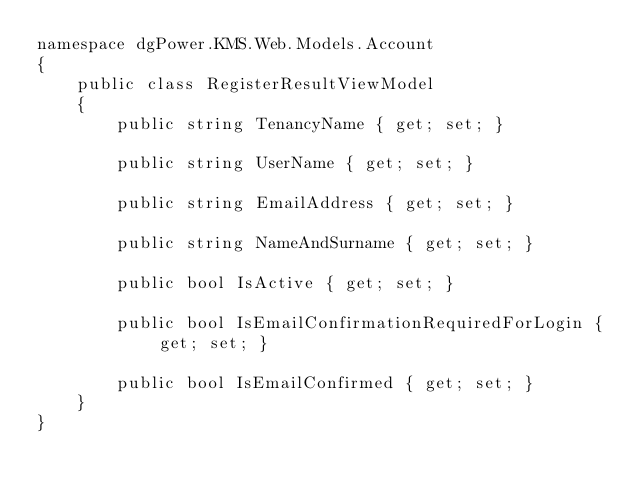Convert code to text. <code><loc_0><loc_0><loc_500><loc_500><_C#_>namespace dgPower.KMS.Web.Models.Account
{
    public class RegisterResultViewModel
    {
        public string TenancyName { get; set; }
        
        public string UserName { get; set; }

        public string EmailAddress { get; set; }
        
        public string NameAndSurname { get; set; }

        public bool IsActive { get; set; }

        public bool IsEmailConfirmationRequiredForLogin { get; set; }

        public bool IsEmailConfirmed { get; set; }
    }
}
</code> 